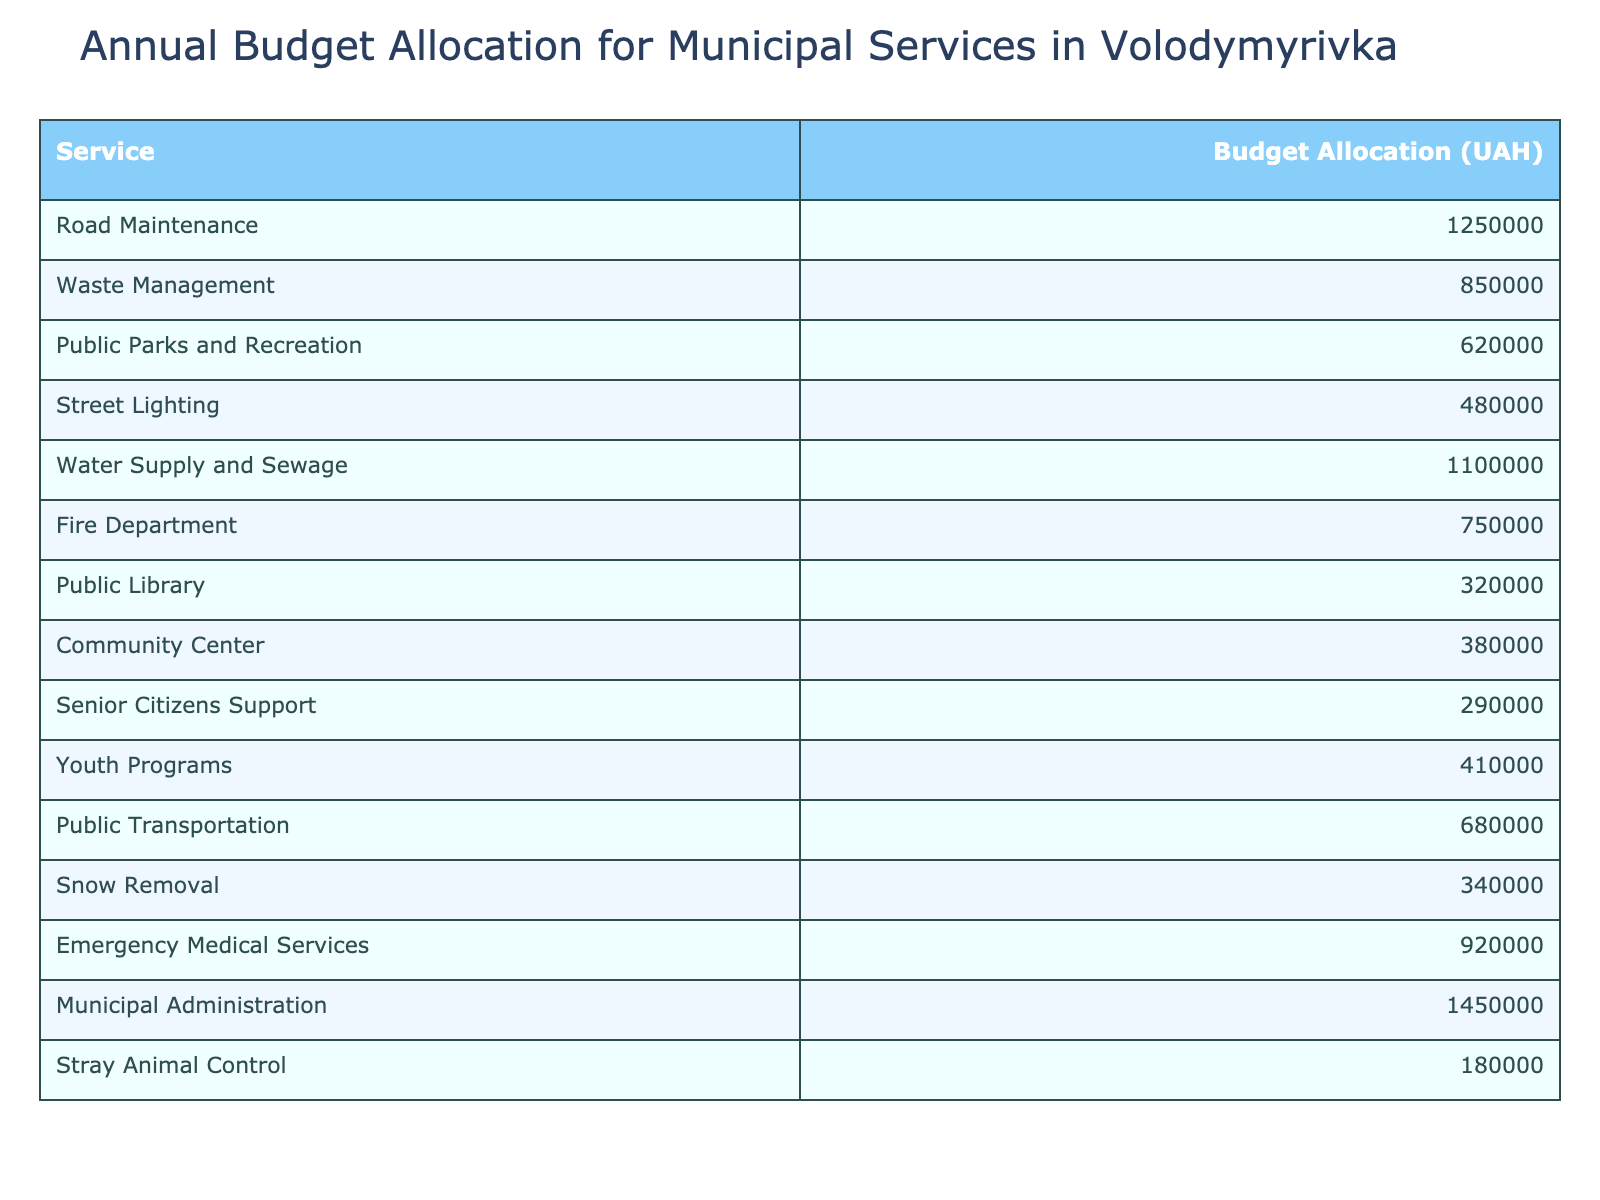What is the budget allocation for Waste Management? The table lists the budget allocation for each service. For Waste Management, the value is explicitly stated as 850,000 UAH.
Answer: 850000 UAH Which service has the highest budget allocation? By comparing all the values in the Budget Allocation column, the highest amount is for Municipal Administration, which is 1,450,000 UAH.
Answer: 1450000 UAH What is the total budget allocation for Public Parks and Recreation and Youth Programs? The budget allocation for Public Parks and Recreation is 620,000 UAH and for Youth Programs is 410,000 UAH. Adding these together (620,000 + 410,000) gives a total of 1,030,000 UAH.
Answer: 1030000 UAH Is the budget allocation for the Fire Department greater than that of Senior Citizens Support? The budget for the Fire Department is 750,000 UAH, while for Senior Citizens Support it is 290,000 UAH. Since 750,000 is greater than 290,000, the statement is true.
Answer: True What is the average budget allocation across all services? To find the average, we first sum all the budget allocations (1,250,000 + 850,000 + 620,000 + 480,000 + 1,100,000 + 750,000 + 320,000 + 380,000 + 290,000 + 410,000 + 680,000 + 340,000 + 920,000 + 1,450,000 + 180,000 = 9,680,000 UAH). Since there are 15 services, we divide the total by 15, resulting in an average of approximately 645,333 UAH.
Answer: 645333 UAH What is the difference in budget allocation between Water Supply and Sewage and Public Library? The budget for Water Supply and Sewage is 1,100,000 UAH and for the Public Library it is 320,000 UAH. The difference is calculated as 1,100,000 - 320,000, which equals 780,000 UAH.
Answer: 780000 UAH How much more budget is allocated to Emergency Medical Services compared to Street Lighting? Emergency Medical Services has a budget of 920,000 UAH and Street Lighting has 480,000 UAH. The difference is calculated as 920,000 - 480,000, which equals 440,000 UAH.
Answer: 440000 UAH What is the total budget allocation for services related to community support (Community Center and Senior Citizens Support)? The budget for Community Center is 380,000 UAH and for Senior Citizens Support is 290,000 UAH. Adding these two budgets together (380,000 + 290,000) results in a total of 670,000 UAH.
Answer: 670000 UAH Is the combined budget for Snow Removal and Public Parks and Recreation less than or equal to 1,000,000 UAH? Snow Removal has a budget allocation of 340,000 UAH and Public Parks and Recreation has 620,000 UAH. Their combined total is 340,000 + 620,000 = 960,000 UAH, which is less than 1,000,000 UAH.
Answer: True Which two services together receive a budget allocation of 1,050,000 UAH? Looking at the table, the combination of Road Maintenance (1,250,000 UAH) and any other service does not yield 1,050,000 UAH, but if we combine Waste Management (850,000 UAH) and Stray Animal Control (180,000 UAH), we get 1,030,000 UAH. However, no two distinct allocations directly equal 1,050,000 UAH based on the data given.
Answer: No such combination exists 